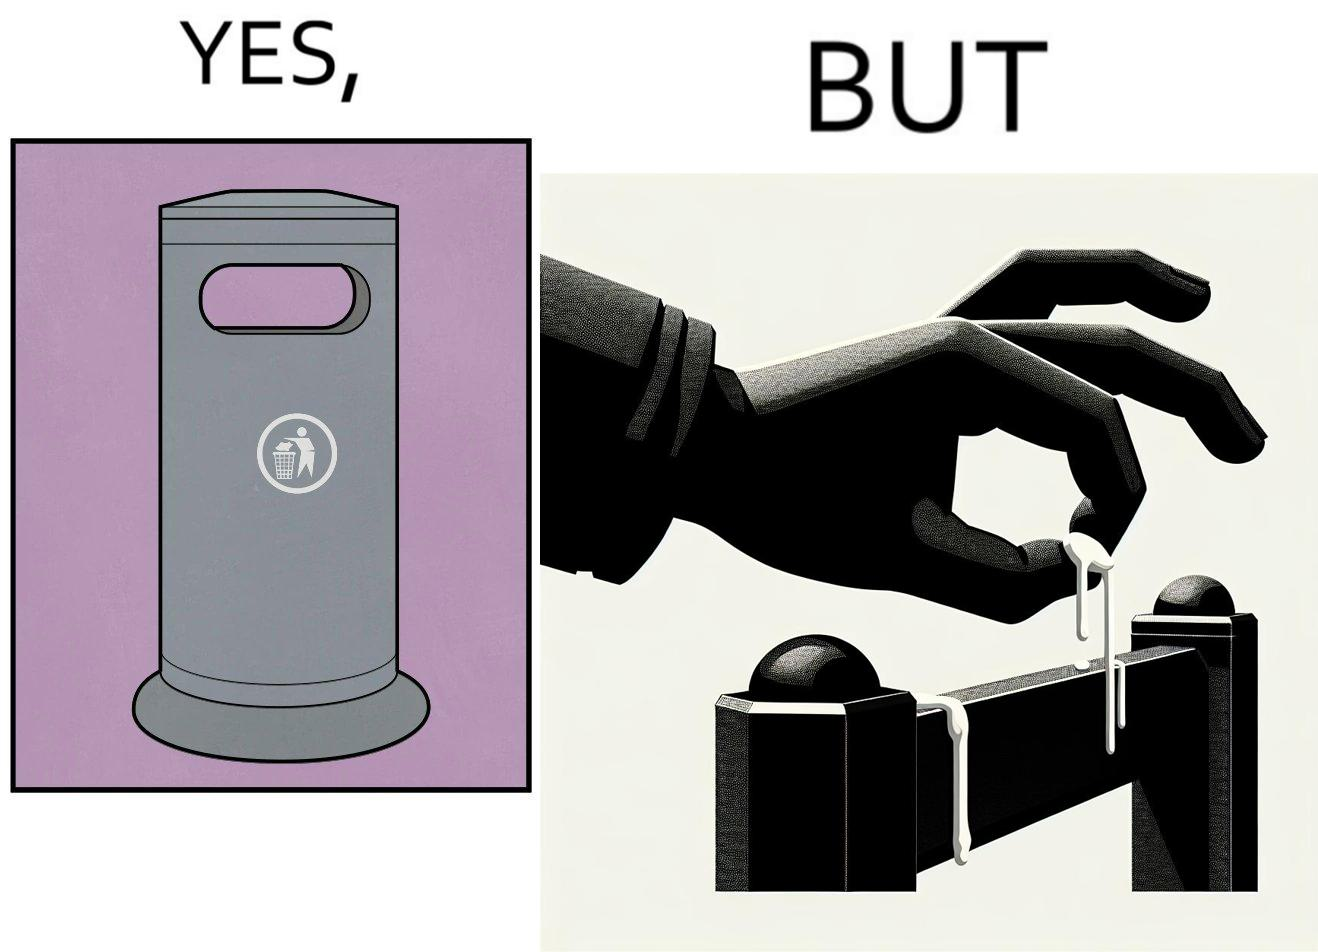Does this image contain satire or humor? Yes, this image is satirical. 